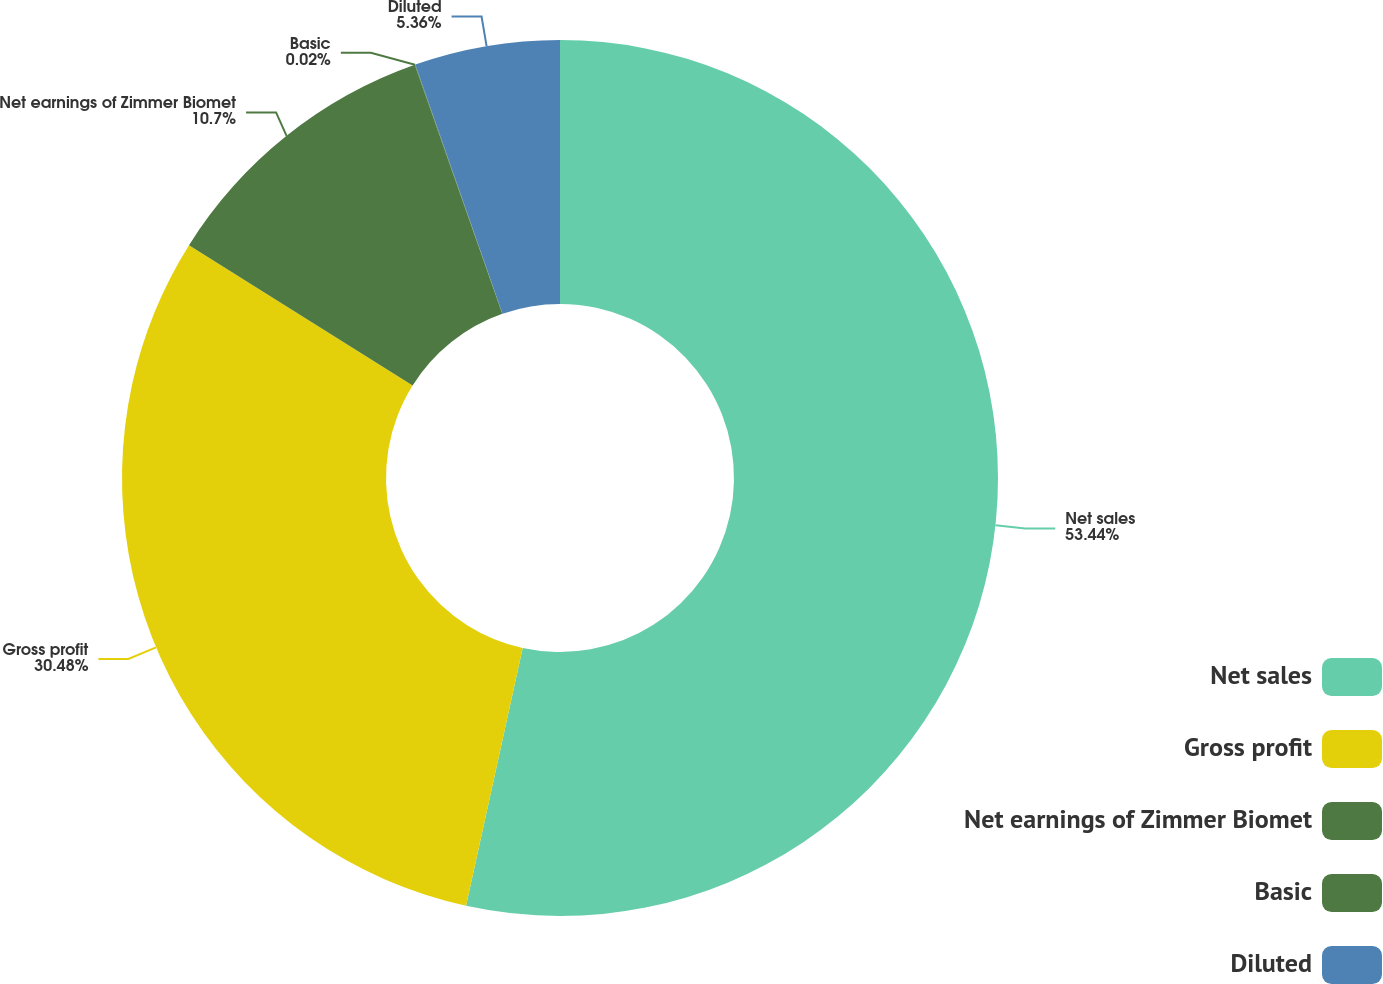<chart> <loc_0><loc_0><loc_500><loc_500><pie_chart><fcel>Net sales<fcel>Gross profit<fcel>Net earnings of Zimmer Biomet<fcel>Basic<fcel>Diluted<nl><fcel>53.44%<fcel>30.48%<fcel>10.7%<fcel>0.02%<fcel>5.36%<nl></chart> 